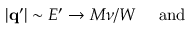<formula> <loc_0><loc_0><loc_500><loc_500>| { q ^ { \prime } } | \sim E ^ { \prime } \rightarrow M \nu / W { a n d }</formula> 